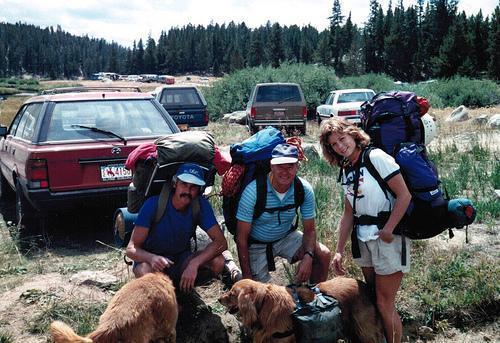How many people are there?
Give a very brief answer. 3. 